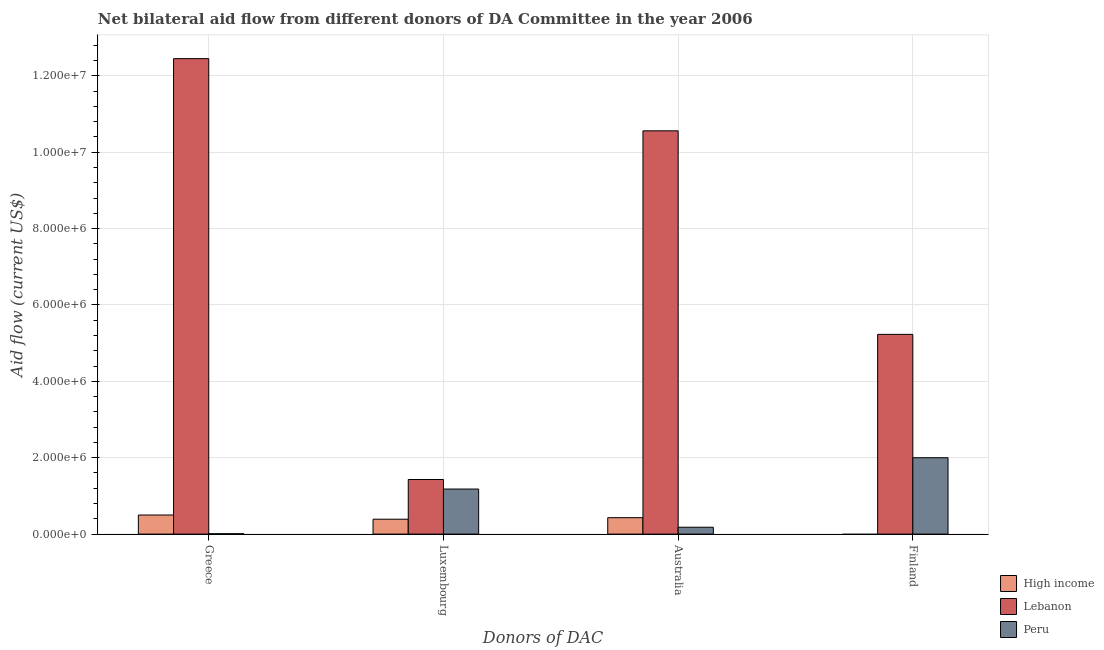How many different coloured bars are there?
Provide a short and direct response. 3. How many groups of bars are there?
Provide a succinct answer. 4. Are the number of bars per tick equal to the number of legend labels?
Your answer should be very brief. No. How many bars are there on the 2nd tick from the right?
Your response must be concise. 3. What is the label of the 2nd group of bars from the left?
Your answer should be compact. Luxembourg. Across all countries, what is the maximum amount of aid given by australia?
Offer a very short reply. 1.06e+07. Across all countries, what is the minimum amount of aid given by finland?
Your answer should be compact. 0. In which country was the amount of aid given by greece maximum?
Ensure brevity in your answer.  Lebanon. What is the total amount of aid given by luxembourg in the graph?
Provide a succinct answer. 3.00e+06. What is the difference between the amount of aid given by australia in Peru and that in Lebanon?
Your answer should be compact. -1.04e+07. What is the difference between the amount of aid given by luxembourg in High income and the amount of aid given by greece in Lebanon?
Ensure brevity in your answer.  -1.21e+07. What is the average amount of aid given by greece per country?
Offer a terse response. 4.32e+06. What is the difference between the amount of aid given by finland and amount of aid given by luxembourg in Lebanon?
Offer a terse response. 3.80e+06. What is the ratio of the amount of aid given by luxembourg in High income to that in Lebanon?
Offer a terse response. 0.27. Is the amount of aid given by greece in Lebanon less than that in High income?
Your answer should be very brief. No. Is the difference between the amount of aid given by luxembourg in Peru and Lebanon greater than the difference between the amount of aid given by finland in Peru and Lebanon?
Give a very brief answer. Yes. What is the difference between the highest and the second highest amount of aid given by australia?
Give a very brief answer. 1.01e+07. What is the difference between the highest and the lowest amount of aid given by finland?
Make the answer very short. 5.23e+06. In how many countries, is the amount of aid given by australia greater than the average amount of aid given by australia taken over all countries?
Provide a succinct answer. 1. Is the sum of the amount of aid given by greece in Peru and Lebanon greater than the maximum amount of aid given by australia across all countries?
Give a very brief answer. Yes. How many bars are there?
Make the answer very short. 11. Are all the bars in the graph horizontal?
Make the answer very short. No. Are the values on the major ticks of Y-axis written in scientific E-notation?
Your answer should be compact. Yes. Does the graph contain any zero values?
Your response must be concise. Yes. Where does the legend appear in the graph?
Ensure brevity in your answer.  Bottom right. How many legend labels are there?
Provide a succinct answer. 3. What is the title of the graph?
Your answer should be compact. Net bilateral aid flow from different donors of DA Committee in the year 2006. What is the label or title of the X-axis?
Your response must be concise. Donors of DAC. What is the label or title of the Y-axis?
Give a very brief answer. Aid flow (current US$). What is the Aid flow (current US$) in High income in Greece?
Offer a very short reply. 5.00e+05. What is the Aid flow (current US$) in Lebanon in Greece?
Offer a very short reply. 1.24e+07. What is the Aid flow (current US$) in Peru in Greece?
Offer a very short reply. 10000. What is the Aid flow (current US$) of Lebanon in Luxembourg?
Your response must be concise. 1.43e+06. What is the Aid flow (current US$) in Peru in Luxembourg?
Provide a succinct answer. 1.18e+06. What is the Aid flow (current US$) in High income in Australia?
Your response must be concise. 4.30e+05. What is the Aid flow (current US$) of Lebanon in Australia?
Your answer should be compact. 1.06e+07. What is the Aid flow (current US$) of Lebanon in Finland?
Keep it short and to the point. 5.23e+06. Across all Donors of DAC, what is the maximum Aid flow (current US$) in Lebanon?
Provide a short and direct response. 1.24e+07. Across all Donors of DAC, what is the minimum Aid flow (current US$) in Lebanon?
Make the answer very short. 1.43e+06. What is the total Aid flow (current US$) in High income in the graph?
Provide a succinct answer. 1.32e+06. What is the total Aid flow (current US$) of Lebanon in the graph?
Offer a very short reply. 2.97e+07. What is the total Aid flow (current US$) in Peru in the graph?
Provide a succinct answer. 3.37e+06. What is the difference between the Aid flow (current US$) in High income in Greece and that in Luxembourg?
Your response must be concise. 1.10e+05. What is the difference between the Aid flow (current US$) of Lebanon in Greece and that in Luxembourg?
Ensure brevity in your answer.  1.10e+07. What is the difference between the Aid flow (current US$) in Peru in Greece and that in Luxembourg?
Your response must be concise. -1.17e+06. What is the difference between the Aid flow (current US$) in Lebanon in Greece and that in Australia?
Ensure brevity in your answer.  1.89e+06. What is the difference between the Aid flow (current US$) in Lebanon in Greece and that in Finland?
Your response must be concise. 7.22e+06. What is the difference between the Aid flow (current US$) of Peru in Greece and that in Finland?
Your answer should be very brief. -1.99e+06. What is the difference between the Aid flow (current US$) of Lebanon in Luxembourg and that in Australia?
Provide a short and direct response. -9.13e+06. What is the difference between the Aid flow (current US$) of Lebanon in Luxembourg and that in Finland?
Offer a terse response. -3.80e+06. What is the difference between the Aid flow (current US$) in Peru in Luxembourg and that in Finland?
Offer a terse response. -8.20e+05. What is the difference between the Aid flow (current US$) in Lebanon in Australia and that in Finland?
Make the answer very short. 5.33e+06. What is the difference between the Aid flow (current US$) in Peru in Australia and that in Finland?
Ensure brevity in your answer.  -1.82e+06. What is the difference between the Aid flow (current US$) in High income in Greece and the Aid flow (current US$) in Lebanon in Luxembourg?
Provide a short and direct response. -9.30e+05. What is the difference between the Aid flow (current US$) of High income in Greece and the Aid flow (current US$) of Peru in Luxembourg?
Keep it short and to the point. -6.80e+05. What is the difference between the Aid flow (current US$) of Lebanon in Greece and the Aid flow (current US$) of Peru in Luxembourg?
Offer a terse response. 1.13e+07. What is the difference between the Aid flow (current US$) of High income in Greece and the Aid flow (current US$) of Lebanon in Australia?
Make the answer very short. -1.01e+07. What is the difference between the Aid flow (current US$) of Lebanon in Greece and the Aid flow (current US$) of Peru in Australia?
Ensure brevity in your answer.  1.23e+07. What is the difference between the Aid flow (current US$) in High income in Greece and the Aid flow (current US$) in Lebanon in Finland?
Offer a very short reply. -4.73e+06. What is the difference between the Aid flow (current US$) of High income in Greece and the Aid flow (current US$) of Peru in Finland?
Make the answer very short. -1.50e+06. What is the difference between the Aid flow (current US$) of Lebanon in Greece and the Aid flow (current US$) of Peru in Finland?
Your response must be concise. 1.04e+07. What is the difference between the Aid flow (current US$) in High income in Luxembourg and the Aid flow (current US$) in Lebanon in Australia?
Provide a succinct answer. -1.02e+07. What is the difference between the Aid flow (current US$) of High income in Luxembourg and the Aid flow (current US$) of Peru in Australia?
Give a very brief answer. 2.10e+05. What is the difference between the Aid flow (current US$) in Lebanon in Luxembourg and the Aid flow (current US$) in Peru in Australia?
Your answer should be very brief. 1.25e+06. What is the difference between the Aid flow (current US$) in High income in Luxembourg and the Aid flow (current US$) in Lebanon in Finland?
Provide a succinct answer. -4.84e+06. What is the difference between the Aid flow (current US$) in High income in Luxembourg and the Aid flow (current US$) in Peru in Finland?
Provide a short and direct response. -1.61e+06. What is the difference between the Aid flow (current US$) in Lebanon in Luxembourg and the Aid flow (current US$) in Peru in Finland?
Offer a very short reply. -5.70e+05. What is the difference between the Aid flow (current US$) in High income in Australia and the Aid flow (current US$) in Lebanon in Finland?
Make the answer very short. -4.80e+06. What is the difference between the Aid flow (current US$) of High income in Australia and the Aid flow (current US$) of Peru in Finland?
Your response must be concise. -1.57e+06. What is the difference between the Aid flow (current US$) in Lebanon in Australia and the Aid flow (current US$) in Peru in Finland?
Your answer should be compact. 8.56e+06. What is the average Aid flow (current US$) in Lebanon per Donors of DAC?
Offer a terse response. 7.42e+06. What is the average Aid flow (current US$) in Peru per Donors of DAC?
Ensure brevity in your answer.  8.42e+05. What is the difference between the Aid flow (current US$) in High income and Aid flow (current US$) in Lebanon in Greece?
Make the answer very short. -1.20e+07. What is the difference between the Aid flow (current US$) in High income and Aid flow (current US$) in Peru in Greece?
Provide a short and direct response. 4.90e+05. What is the difference between the Aid flow (current US$) of Lebanon and Aid flow (current US$) of Peru in Greece?
Ensure brevity in your answer.  1.24e+07. What is the difference between the Aid flow (current US$) in High income and Aid flow (current US$) in Lebanon in Luxembourg?
Keep it short and to the point. -1.04e+06. What is the difference between the Aid flow (current US$) in High income and Aid flow (current US$) in Peru in Luxembourg?
Offer a terse response. -7.90e+05. What is the difference between the Aid flow (current US$) in Lebanon and Aid flow (current US$) in Peru in Luxembourg?
Ensure brevity in your answer.  2.50e+05. What is the difference between the Aid flow (current US$) in High income and Aid flow (current US$) in Lebanon in Australia?
Offer a terse response. -1.01e+07. What is the difference between the Aid flow (current US$) of Lebanon and Aid flow (current US$) of Peru in Australia?
Give a very brief answer. 1.04e+07. What is the difference between the Aid flow (current US$) in Lebanon and Aid flow (current US$) in Peru in Finland?
Provide a short and direct response. 3.23e+06. What is the ratio of the Aid flow (current US$) of High income in Greece to that in Luxembourg?
Offer a very short reply. 1.28. What is the ratio of the Aid flow (current US$) in Lebanon in Greece to that in Luxembourg?
Make the answer very short. 8.71. What is the ratio of the Aid flow (current US$) in Peru in Greece to that in Luxembourg?
Make the answer very short. 0.01. What is the ratio of the Aid flow (current US$) of High income in Greece to that in Australia?
Make the answer very short. 1.16. What is the ratio of the Aid flow (current US$) of Lebanon in Greece to that in Australia?
Keep it short and to the point. 1.18. What is the ratio of the Aid flow (current US$) of Peru in Greece to that in Australia?
Your response must be concise. 0.06. What is the ratio of the Aid flow (current US$) in Lebanon in Greece to that in Finland?
Your response must be concise. 2.38. What is the ratio of the Aid flow (current US$) of Peru in Greece to that in Finland?
Offer a terse response. 0.01. What is the ratio of the Aid flow (current US$) of High income in Luxembourg to that in Australia?
Offer a terse response. 0.91. What is the ratio of the Aid flow (current US$) in Lebanon in Luxembourg to that in Australia?
Your response must be concise. 0.14. What is the ratio of the Aid flow (current US$) in Peru in Luxembourg to that in Australia?
Offer a terse response. 6.56. What is the ratio of the Aid flow (current US$) in Lebanon in Luxembourg to that in Finland?
Your answer should be compact. 0.27. What is the ratio of the Aid flow (current US$) of Peru in Luxembourg to that in Finland?
Provide a succinct answer. 0.59. What is the ratio of the Aid flow (current US$) in Lebanon in Australia to that in Finland?
Your answer should be very brief. 2.02. What is the ratio of the Aid flow (current US$) of Peru in Australia to that in Finland?
Provide a short and direct response. 0.09. What is the difference between the highest and the second highest Aid flow (current US$) of High income?
Provide a short and direct response. 7.00e+04. What is the difference between the highest and the second highest Aid flow (current US$) in Lebanon?
Keep it short and to the point. 1.89e+06. What is the difference between the highest and the second highest Aid flow (current US$) in Peru?
Give a very brief answer. 8.20e+05. What is the difference between the highest and the lowest Aid flow (current US$) in High income?
Give a very brief answer. 5.00e+05. What is the difference between the highest and the lowest Aid flow (current US$) in Lebanon?
Your answer should be compact. 1.10e+07. What is the difference between the highest and the lowest Aid flow (current US$) of Peru?
Your answer should be compact. 1.99e+06. 